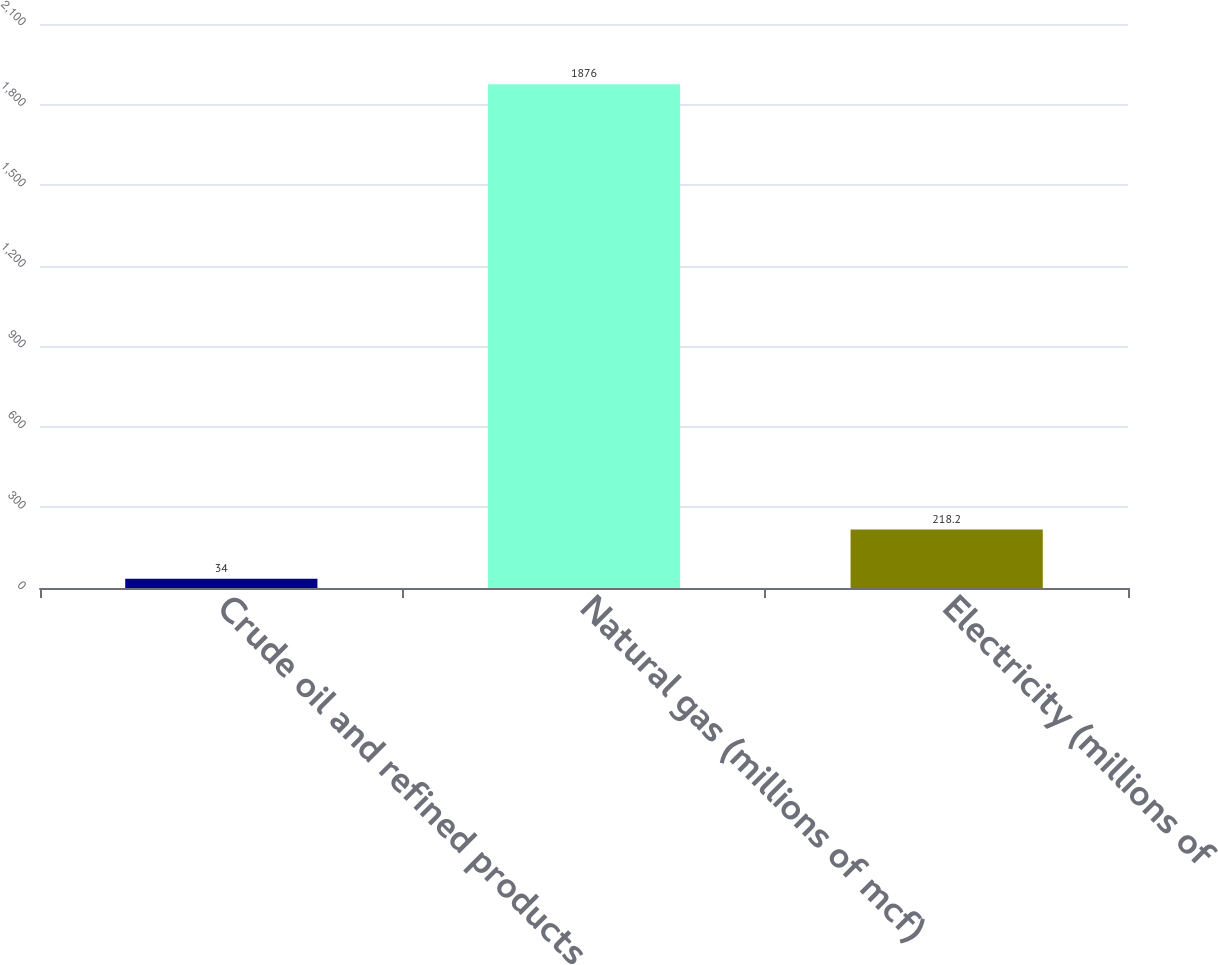<chart> <loc_0><loc_0><loc_500><loc_500><bar_chart><fcel>Crude oil and refined products<fcel>Natural gas (millions of mcf)<fcel>Electricity (millions of<nl><fcel>34<fcel>1876<fcel>218.2<nl></chart> 